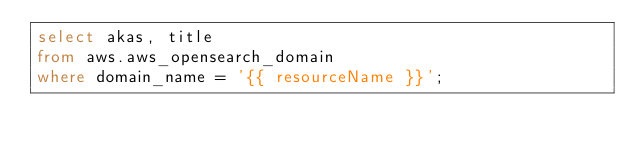Convert code to text. <code><loc_0><loc_0><loc_500><loc_500><_SQL_>select akas, title
from aws.aws_opensearch_domain
where domain_name = '{{ resourceName }}';</code> 